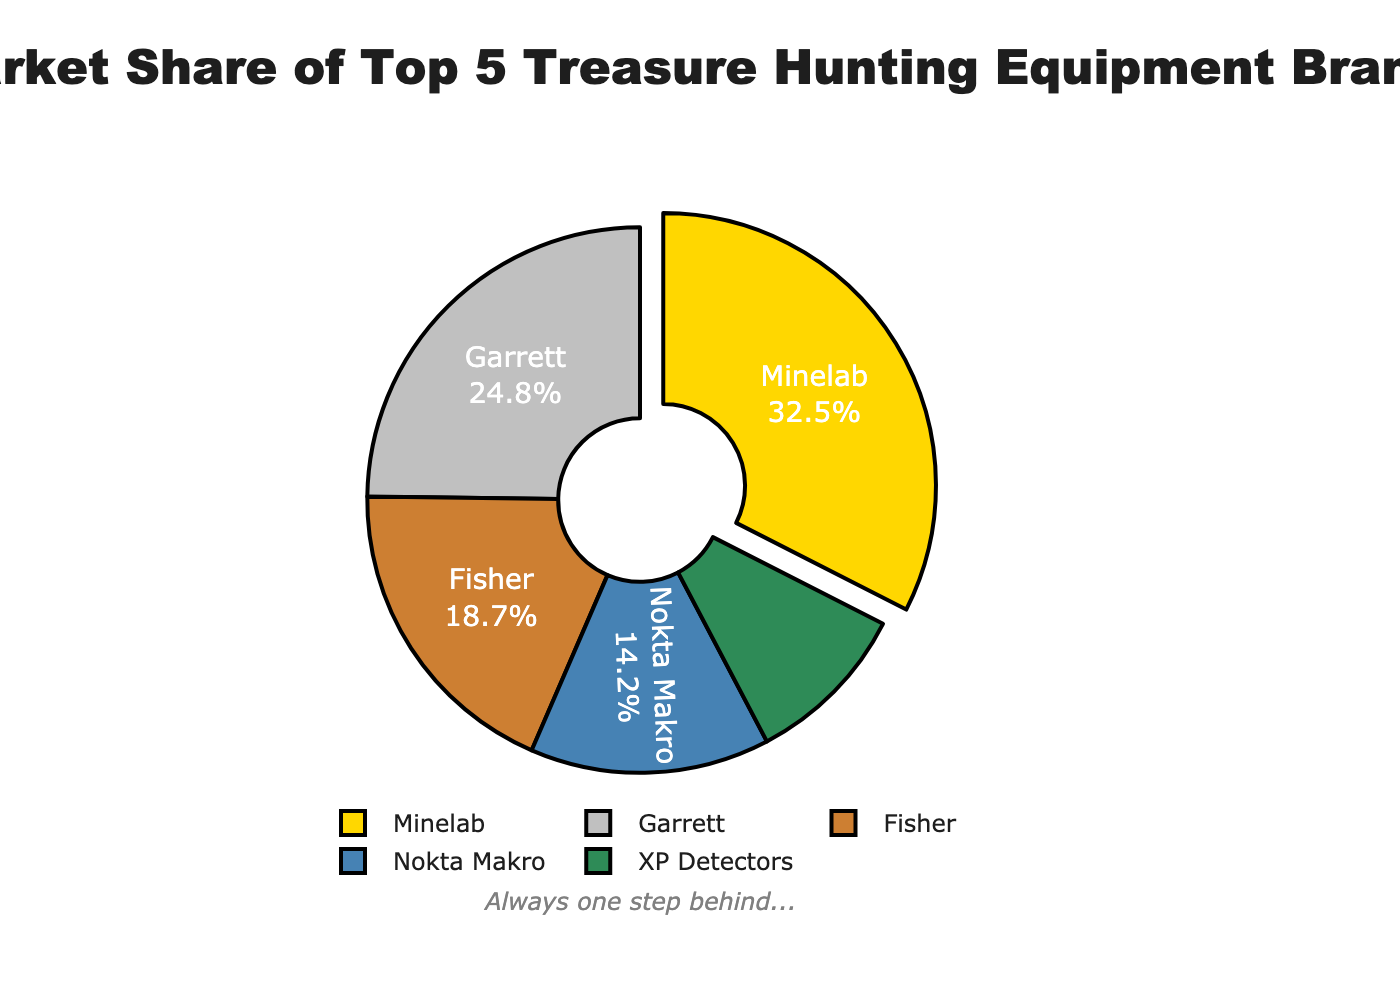Which brand has the highest market share? From the pie chart, Minelab has the largest segment, and it is labeled with 32.5%.
Answer: Minelab What percentage of the market do the top two brands combined hold? Minelab holds 32.5% and Garrett holds 24.8%. Adding these together gives \(32.5 + 24.8 = 57.3\).
Answer: 57.3% Which brand holds the smallest market share? XP Detectors has the smallest segment in the pie chart, labeled with 9.8%.
Answer: XP Detectors How much more market share does Minelab have compared to Fisher? Minelab has 32.5% and Fisher has 18.7%. The difference is \(32.5 - 18.7 = 13.8\).
Answer: 13.8% Is Garrett's market share greater than Nokta Makro and XP Detectors combined? Garrett has 24.8%, while Nokta Makro has 14.2% and XP Detectors has 9.8%. Combined, Nokta Makro and XP Detectors have \(14.2 + 9.8 = 24\). Since \(24.8 > 24\), Garrett's market share is indeed greater.
Answer: Yes What is the average market share of the top five brands? The market shares are 32.5, 24.8, 18.7, 14.2, and 9.8. The sum is \(32.5 + 24.8 + 18.7 + 14.2 + 9.8 = 100.0\). There are 5 brands, so the average is \(100.0 / 5 = 20\).
Answer: 20% Which brand’s segment is visually pulled out from the pie chart? The segment for Minelab is separated slightly from the rest, indicating it's pulled out.
Answer: Minelab By how many percentage points does Garrett's market share exceed Nokta Makro's? Garrett has 24.8% and Nokta Makro has 14.2%. The difference is \(24.8 - 14.2 = 10.6\).
Answer: 10.6 What is the collective market share of Fisher, Nokta Makro, and XP Detectors? Fisher has 18.7%, Nokta Makro has 14.2%, and XP Detectors has 9.8%. The sum is \(18.7 + 14.2 + 9.8 = 42.7\).
Answer: 42.7% What color represents Garrett in the pie chart? Garrett's segment is the second in order and is represented with a silver color.
Answer: Silver 